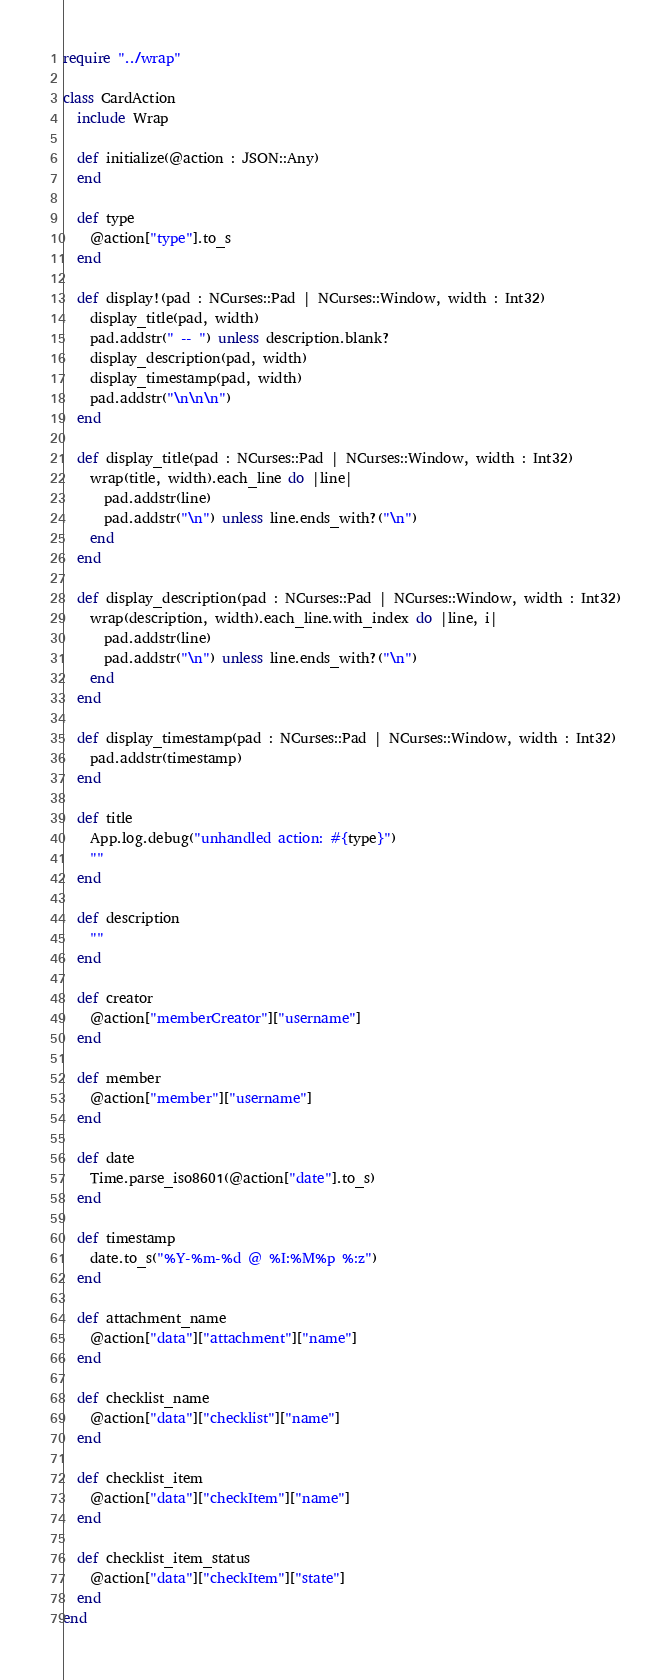Convert code to text. <code><loc_0><loc_0><loc_500><loc_500><_Crystal_>require "../wrap"

class CardAction
  include Wrap

  def initialize(@action : JSON::Any)
  end

  def type
    @action["type"].to_s
  end

  def display!(pad : NCurses::Pad | NCurses::Window, width : Int32)
    display_title(pad, width)
    pad.addstr(" -- ") unless description.blank?
    display_description(pad, width)
    display_timestamp(pad, width)
    pad.addstr("\n\n\n")
  end

  def display_title(pad : NCurses::Pad | NCurses::Window, width : Int32)
    wrap(title, width).each_line do |line|
      pad.addstr(line)
      pad.addstr("\n") unless line.ends_with?("\n")
    end
  end

  def display_description(pad : NCurses::Pad | NCurses::Window, width : Int32)
    wrap(description, width).each_line.with_index do |line, i|
      pad.addstr(line)
      pad.addstr("\n") unless line.ends_with?("\n")
    end
  end

  def display_timestamp(pad : NCurses::Pad | NCurses::Window, width : Int32)
    pad.addstr(timestamp)
  end

  def title
    App.log.debug("unhandled action: #{type}")
    ""
  end

  def description
    ""
  end

  def creator
    @action["memberCreator"]["username"]
  end

  def member
    @action["member"]["username"]
  end

  def date
    Time.parse_iso8601(@action["date"].to_s)
  end

  def timestamp
    date.to_s("%Y-%m-%d @ %I:%M%p %:z")
  end

  def attachment_name
    @action["data"]["attachment"]["name"]
  end

  def checklist_name
    @action["data"]["checklist"]["name"]
  end

  def checklist_item
    @action["data"]["checkItem"]["name"]
  end

  def checklist_item_status
    @action["data"]["checkItem"]["state"]
  end
end
</code> 